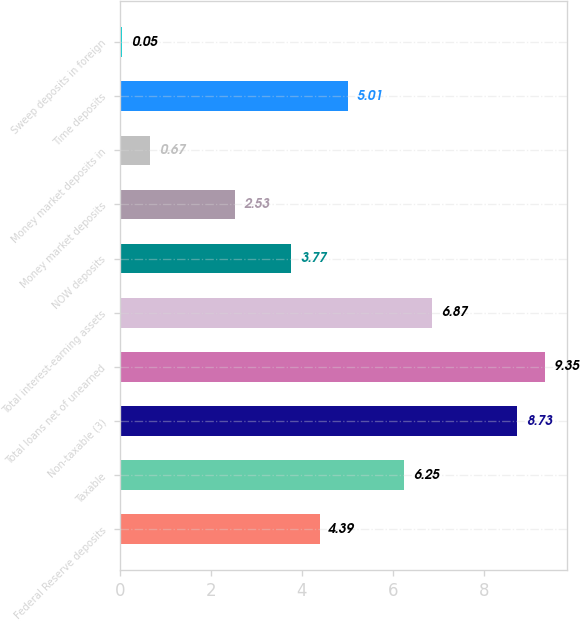Convert chart. <chart><loc_0><loc_0><loc_500><loc_500><bar_chart><fcel>Federal Reserve deposits<fcel>Taxable<fcel>Non-taxable (3)<fcel>Total loans net of unearned<fcel>Total interest-earning assets<fcel>NOW deposits<fcel>Money market deposits<fcel>Money market deposits in<fcel>Time deposits<fcel>Sweep deposits in foreign<nl><fcel>4.39<fcel>6.25<fcel>8.73<fcel>9.35<fcel>6.87<fcel>3.77<fcel>2.53<fcel>0.67<fcel>5.01<fcel>0.05<nl></chart> 